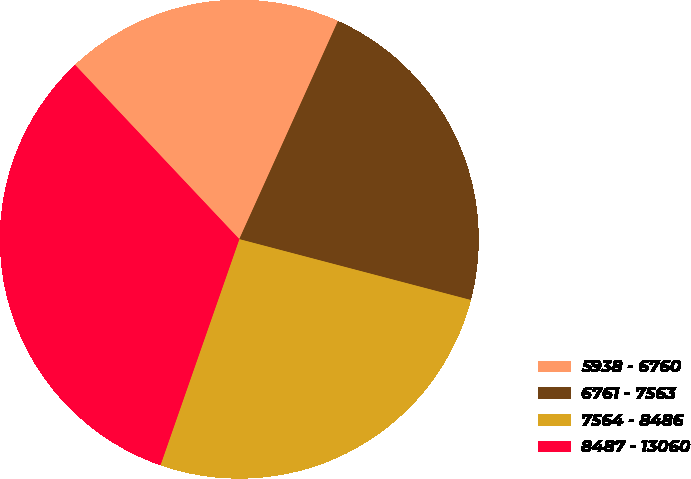Convert chart. <chart><loc_0><loc_0><loc_500><loc_500><pie_chart><fcel>5938 - 6760<fcel>6761 - 7563<fcel>7564 - 8486<fcel>8487 - 13060<nl><fcel>18.79%<fcel>22.33%<fcel>26.25%<fcel>32.63%<nl></chart> 